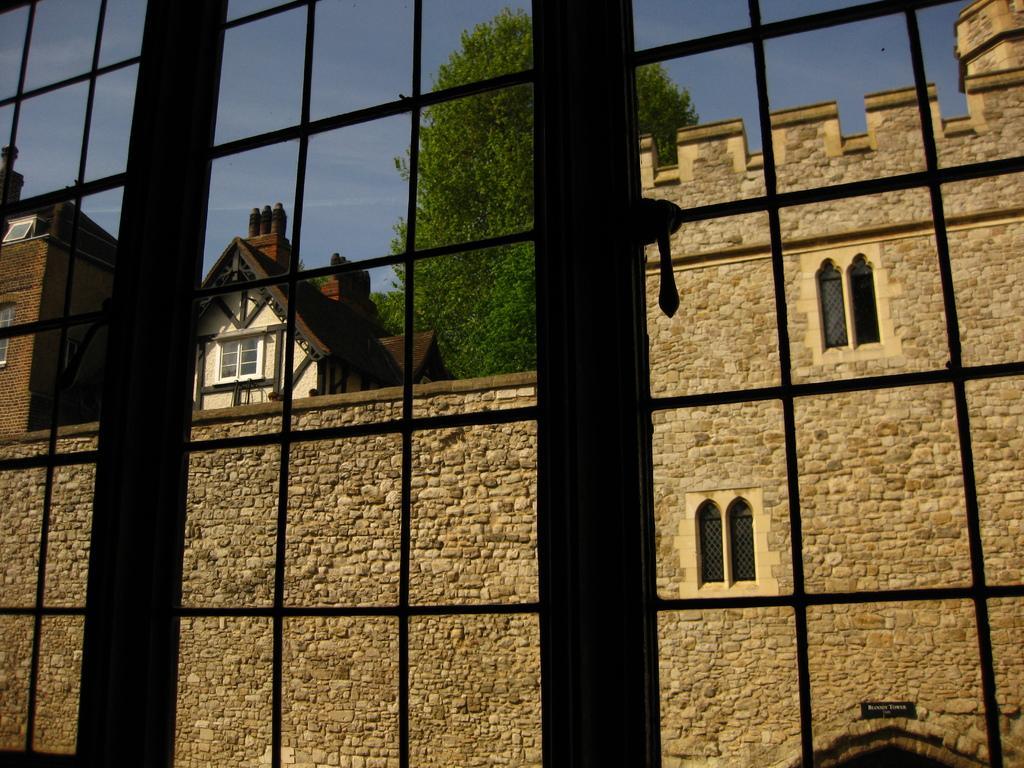Please provide a concise description of this image. In this picture I can see bars and in the background I see the buildings, a tree and the sky. 